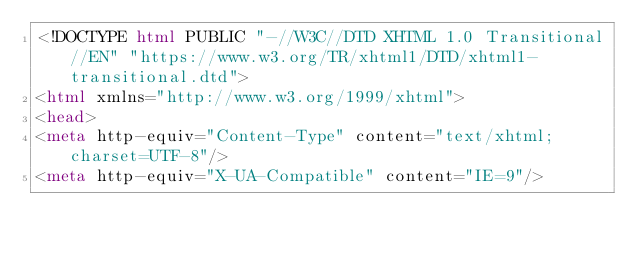Convert code to text. <code><loc_0><loc_0><loc_500><loc_500><_HTML_><!DOCTYPE html PUBLIC "-//W3C//DTD XHTML 1.0 Transitional//EN" "https://www.w3.org/TR/xhtml1/DTD/xhtml1-transitional.dtd">
<html xmlns="http://www.w3.org/1999/xhtml">
<head>
<meta http-equiv="Content-Type" content="text/xhtml;charset=UTF-8"/>
<meta http-equiv="X-UA-Compatible" content="IE=9"/></code> 